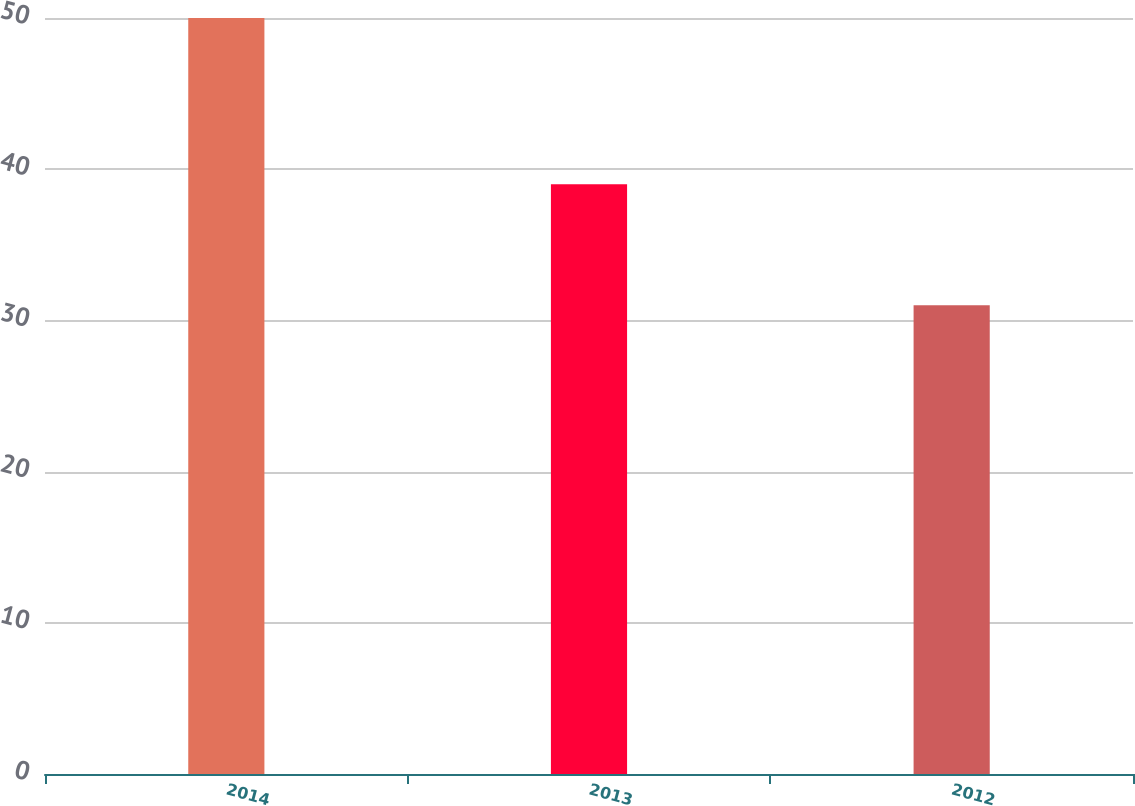Convert chart. <chart><loc_0><loc_0><loc_500><loc_500><bar_chart><fcel>2014<fcel>2013<fcel>2012<nl><fcel>50<fcel>39<fcel>31<nl></chart> 